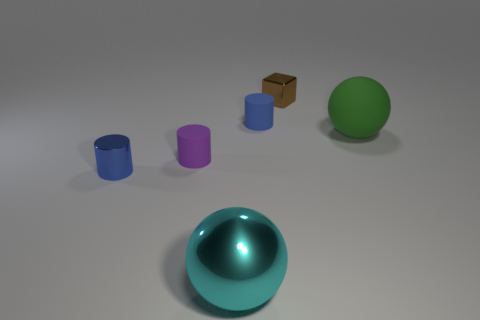Subtract 2 cylinders. How many cylinders are left? 1 Add 2 tiny purple rubber cylinders. How many objects exist? 8 Subtract all blue cylinders. How many cylinders are left? 1 Subtract all matte cylinders. How many cylinders are left? 1 Subtract 0 red balls. How many objects are left? 6 Subtract all cubes. How many objects are left? 5 Subtract all cyan blocks. Subtract all yellow balls. How many blocks are left? 1 Subtract all gray spheres. How many cyan blocks are left? 0 Subtract all large cyan shiny cylinders. Subtract all big green rubber balls. How many objects are left? 5 Add 3 small blue rubber cylinders. How many small blue rubber cylinders are left? 4 